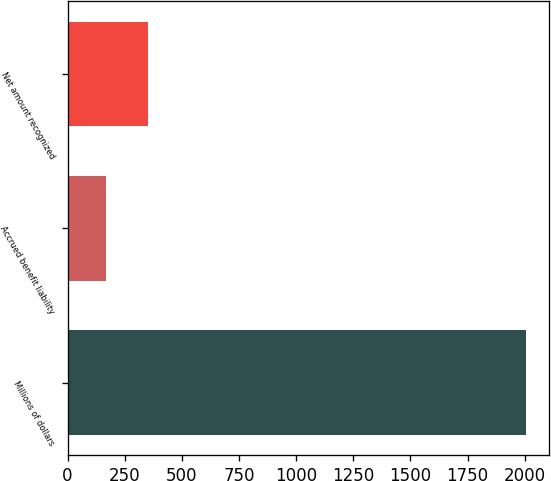Convert chart. <chart><loc_0><loc_0><loc_500><loc_500><bar_chart><fcel>Millions of dollars<fcel>Accrued benefit liability<fcel>Net amount recognized<nl><fcel>2005<fcel>168<fcel>351.7<nl></chart> 